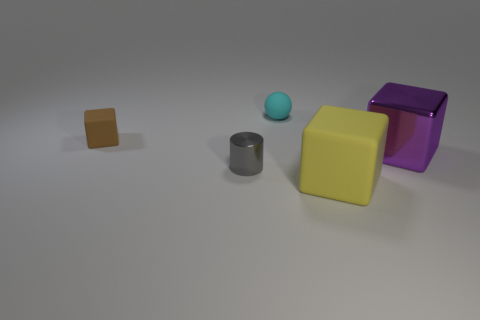Add 4 large cubes. How many objects exist? 9 Subtract all cylinders. How many objects are left? 4 Add 1 small brown matte blocks. How many small brown matte blocks are left? 2 Add 1 yellow matte blocks. How many yellow matte blocks exist? 2 Subtract 0 blue cylinders. How many objects are left? 5 Subtract all small matte blocks. Subtract all cubes. How many objects are left? 1 